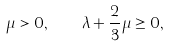<formula> <loc_0><loc_0><loc_500><loc_500>\mu > 0 , \quad \lambda + \frac { 2 } { 3 } \mu \geq 0 ,</formula> 